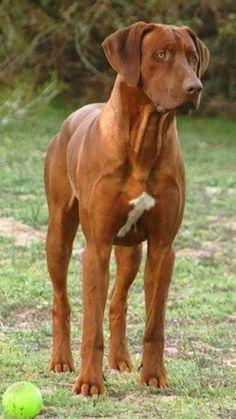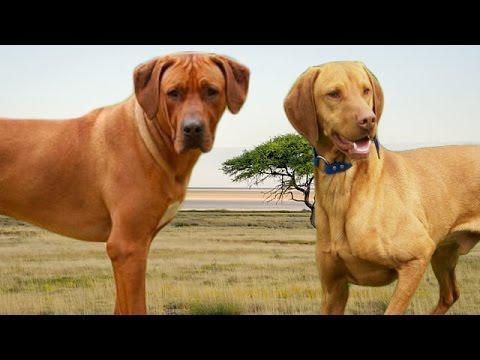The first image is the image on the left, the second image is the image on the right. Assess this claim about the two images: "The right image contains exactly two dogs.". Correct or not? Answer yes or no. Yes. The first image is the image on the left, the second image is the image on the right. Examine the images to the left and right. Is the description "One image includes a sitting dog wearing a collar, and the other image features a dog with one raised front paw." accurate? Answer yes or no. No. 